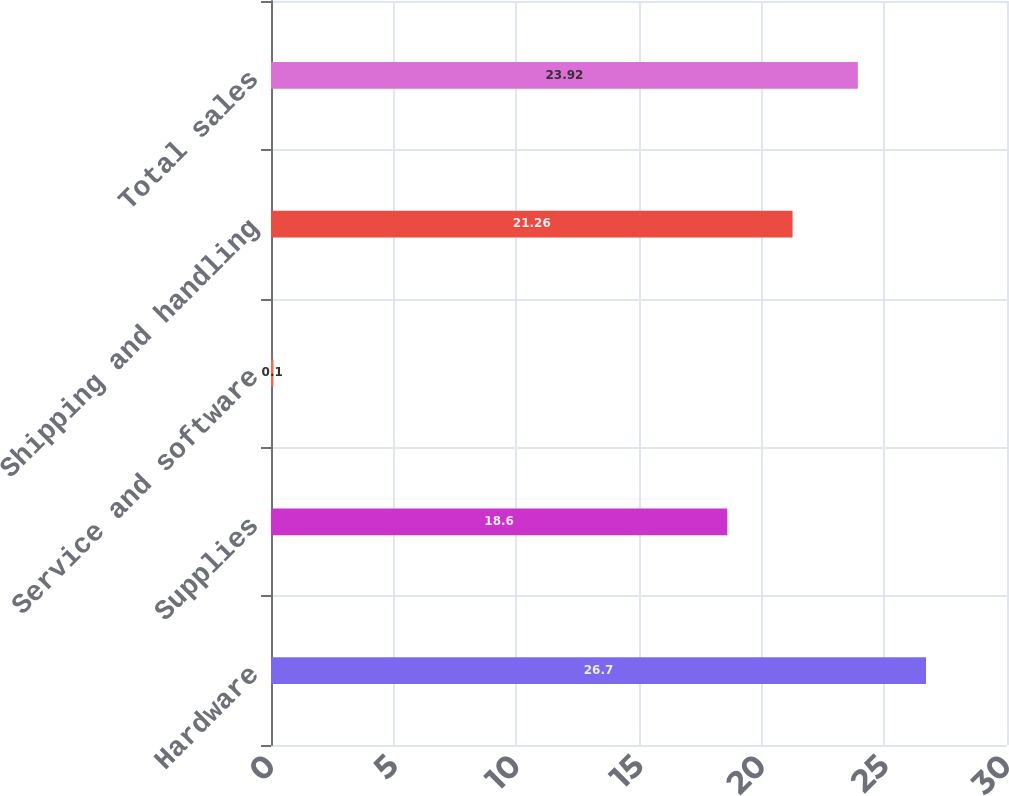Convert chart to OTSL. <chart><loc_0><loc_0><loc_500><loc_500><bar_chart><fcel>Hardware<fcel>Supplies<fcel>Service and software<fcel>Shipping and handling<fcel>Total sales<nl><fcel>26.7<fcel>18.6<fcel>0.1<fcel>21.26<fcel>23.92<nl></chart> 